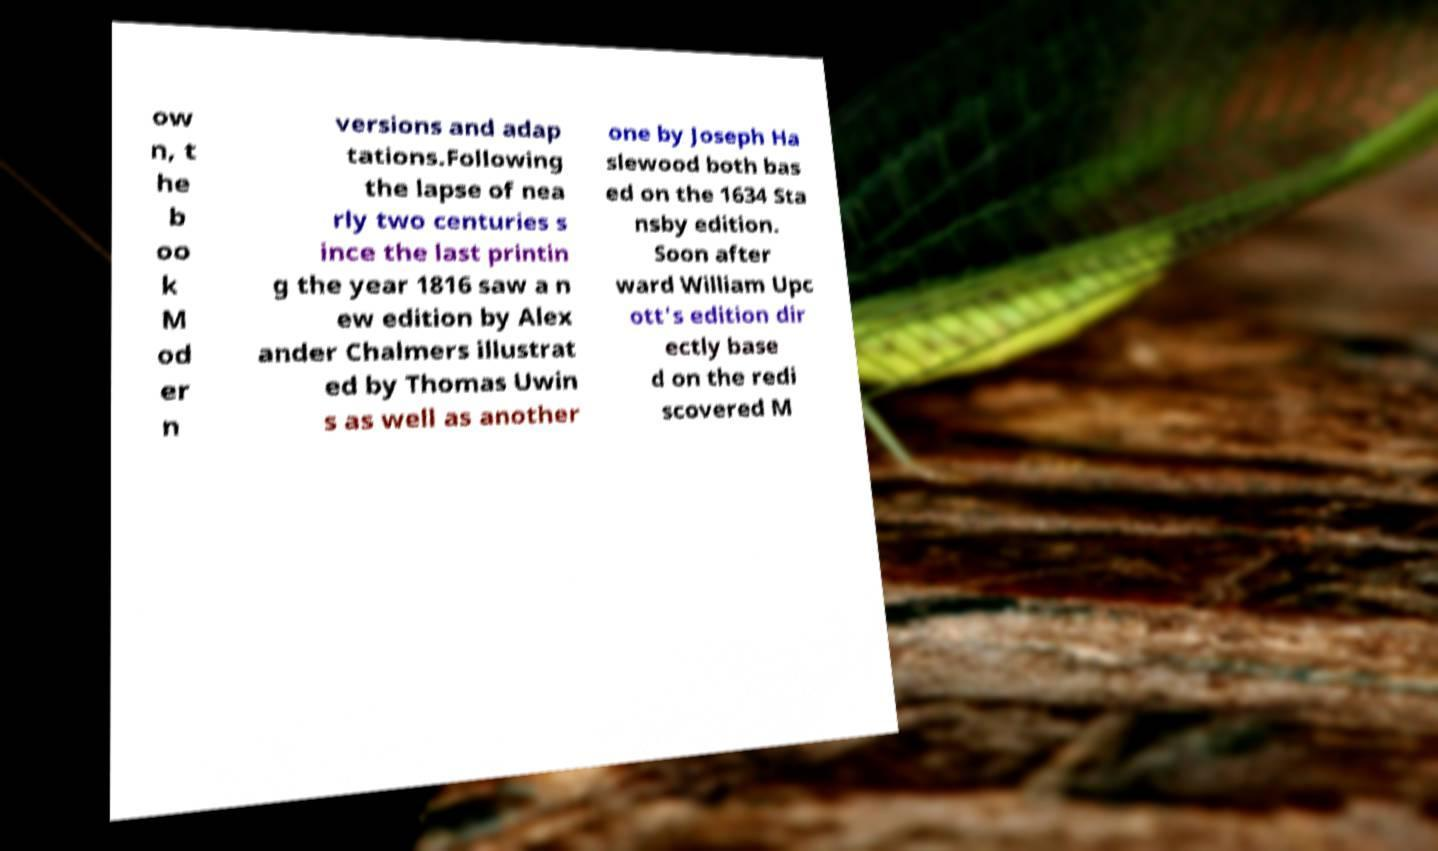Please identify and transcribe the text found in this image. ow n, t he b oo k M od er n versions and adap tations.Following the lapse of nea rly two centuries s ince the last printin g the year 1816 saw a n ew edition by Alex ander Chalmers illustrat ed by Thomas Uwin s as well as another one by Joseph Ha slewood both bas ed on the 1634 Sta nsby edition. Soon after ward William Upc ott's edition dir ectly base d on the redi scovered M 